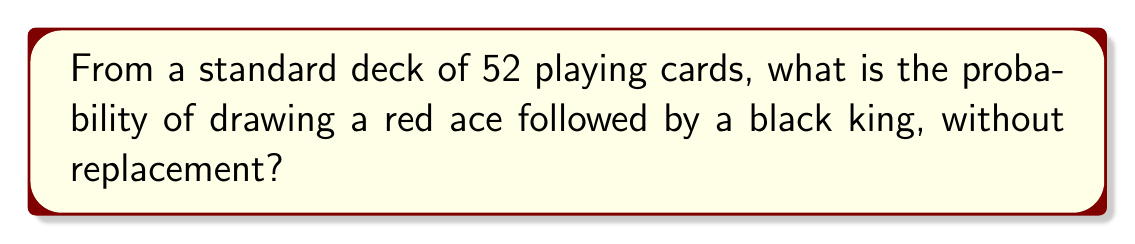Help me with this question. Let's approach this step-by-step:

1) First, we need to calculate the probability of drawing a red ace:
   - There are 2 red aces (hearts and diamonds) out of 52 cards
   - $P(\text{red ace}) = \frac{2}{52} = \frac{1}{26}$

2) After drawing a red ace, we have 51 cards left, and we need to draw a black king:
   - There are 2 black kings (spades and clubs) out of 51 remaining cards
   - $P(\text{black king} | \text{red ace}) = \frac{2}{51}$

3) The probability of both events occurring is the product of their individual probabilities:

   $$P(\text{red ace and black king}) = P(\text{red ace}) \times P(\text{black king} | \text{red ace})$$

   $$= \frac{1}{26} \times \frac{2}{51}$$

4) Simplifying:
   
   $$= \frac{1 \times 2}{26 \times 51} = \frac{2}{1326}$$

Therefore, the probability of drawing a red ace followed by a black king, without replacement, is $\frac{2}{1326}$.
Answer: $\frac{2}{1326}$ 